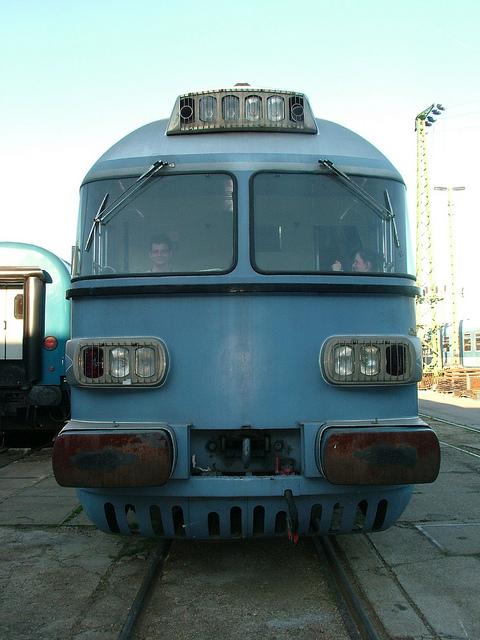Is the train old?
Give a very brief answer. Yes. Is this a red bus or blue bus?
Short answer required. Blue. How many windshield wipers does this train have?
Keep it brief. 2. What is the color blue on the car made out of?
Short answer required. Paint. Is this from a kids' movie?
Quick response, please. No. What color is the train?
Write a very short answer. Blue. What color is the second train?
Answer briefly. Blue. 